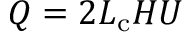<formula> <loc_0><loc_0><loc_500><loc_500>Q = 2 L _ { c } H U</formula> 